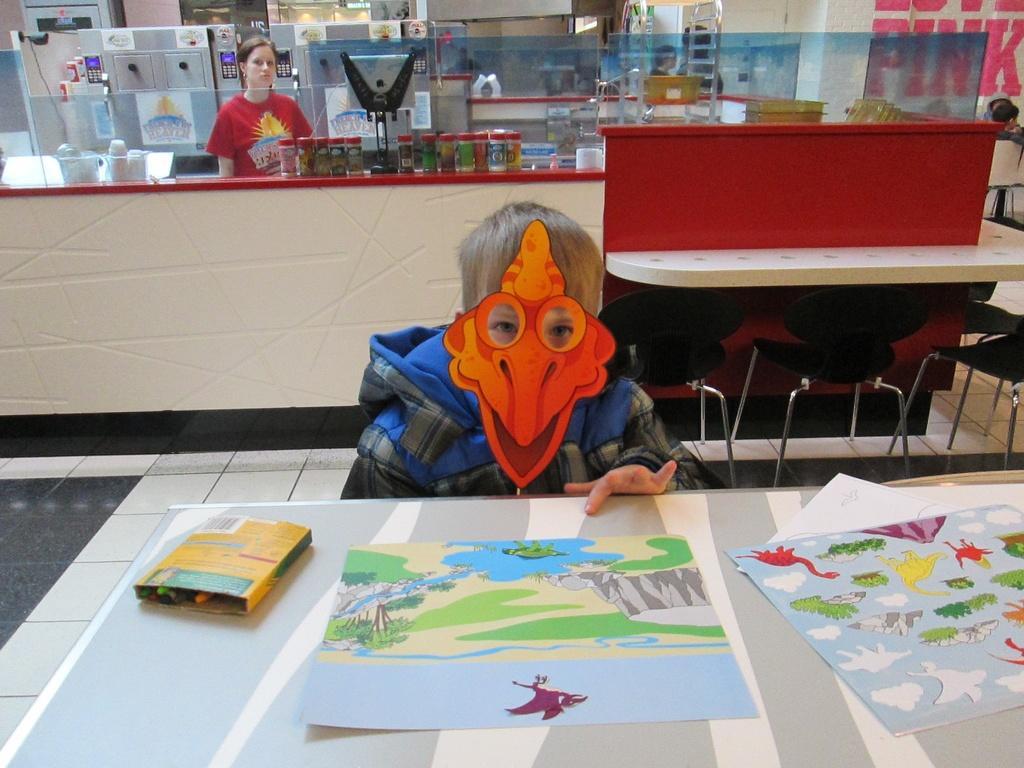How would you summarize this image in a sentence or two? In the image we can see there is a kid sitting on the chair and he is wearing mask on his face. There are cartoons drawn on the paper and kept on the table. 